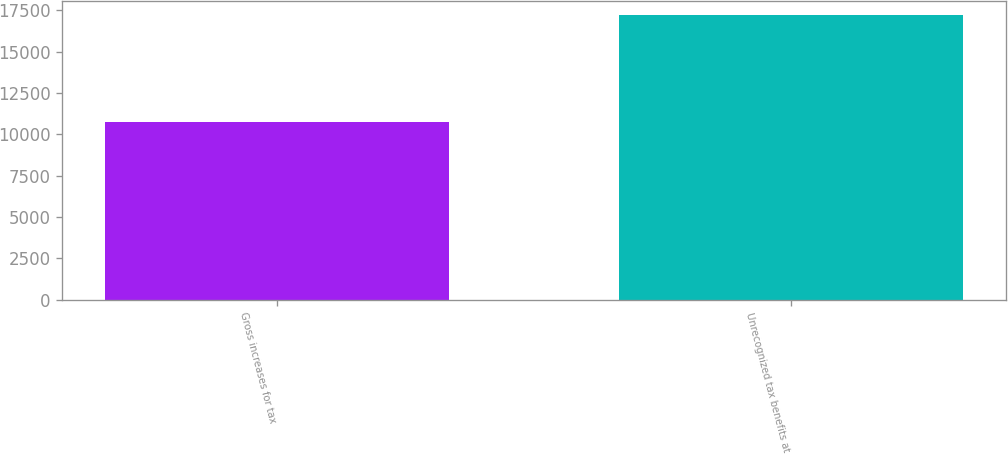<chart> <loc_0><loc_0><loc_500><loc_500><bar_chart><fcel>Gross increases for tax<fcel>Unrecognized tax benefits at<nl><fcel>10750<fcel>17214<nl></chart> 